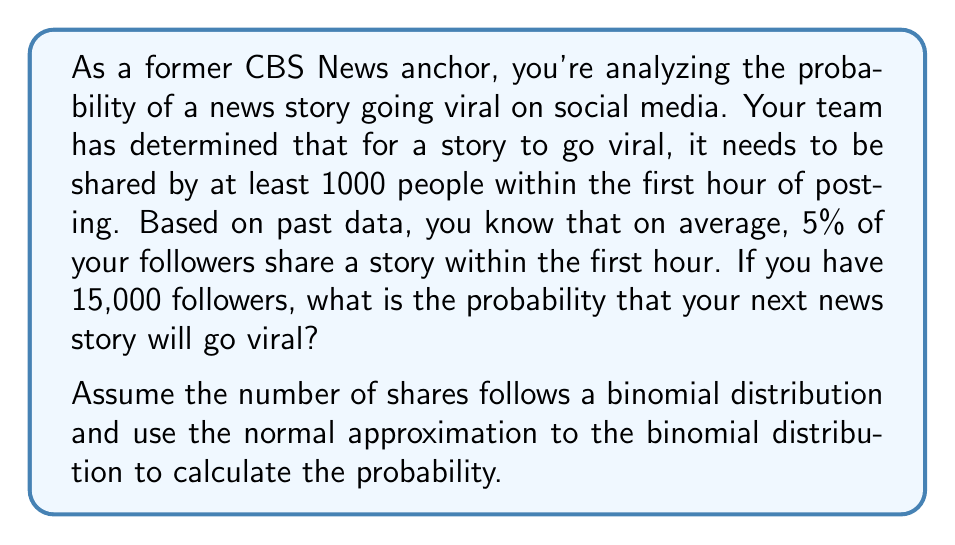Provide a solution to this math problem. To solve this problem, we'll use the normal approximation to the binomial distribution. Let's break it down step-by-step:

1) First, let's identify our parameters:
   $n = 15,000$ (number of followers)
   $p = 0.05$ (probability of a follower sharing)
   $X =$ number of shares (random variable)
   We want $P(X \geq 1000)$

2) For a binomial distribution:
   $\mu = np = 15,000 \times 0.05 = 750$
   $\sigma = \sqrt{np(1-p)} = \sqrt{15,000 \times 0.05 \times 0.95} = \sqrt{712.5} \approx 26.69$

3) To use the normal approximation, we need to apply a continuity correction. We're looking for $P(X \geq 1000)$, so we'll use 999.5 as our lower bound:
   $z = \frac{999.5 - 750}{26.69} \approx 9.35$

4) Now we need to find $P(Z > 9.35)$ where $Z$ is a standard normal variable.

5) Using a standard normal table or calculator, we find:
   $P(Z > 9.35) \approx 0$

6) Therefore, $P(X \geq 1000) \approx 0$

This means the probability is extremely small, effectively zero to several decimal places.
Answer: The probability that the news story will go viral is approximately 0. 